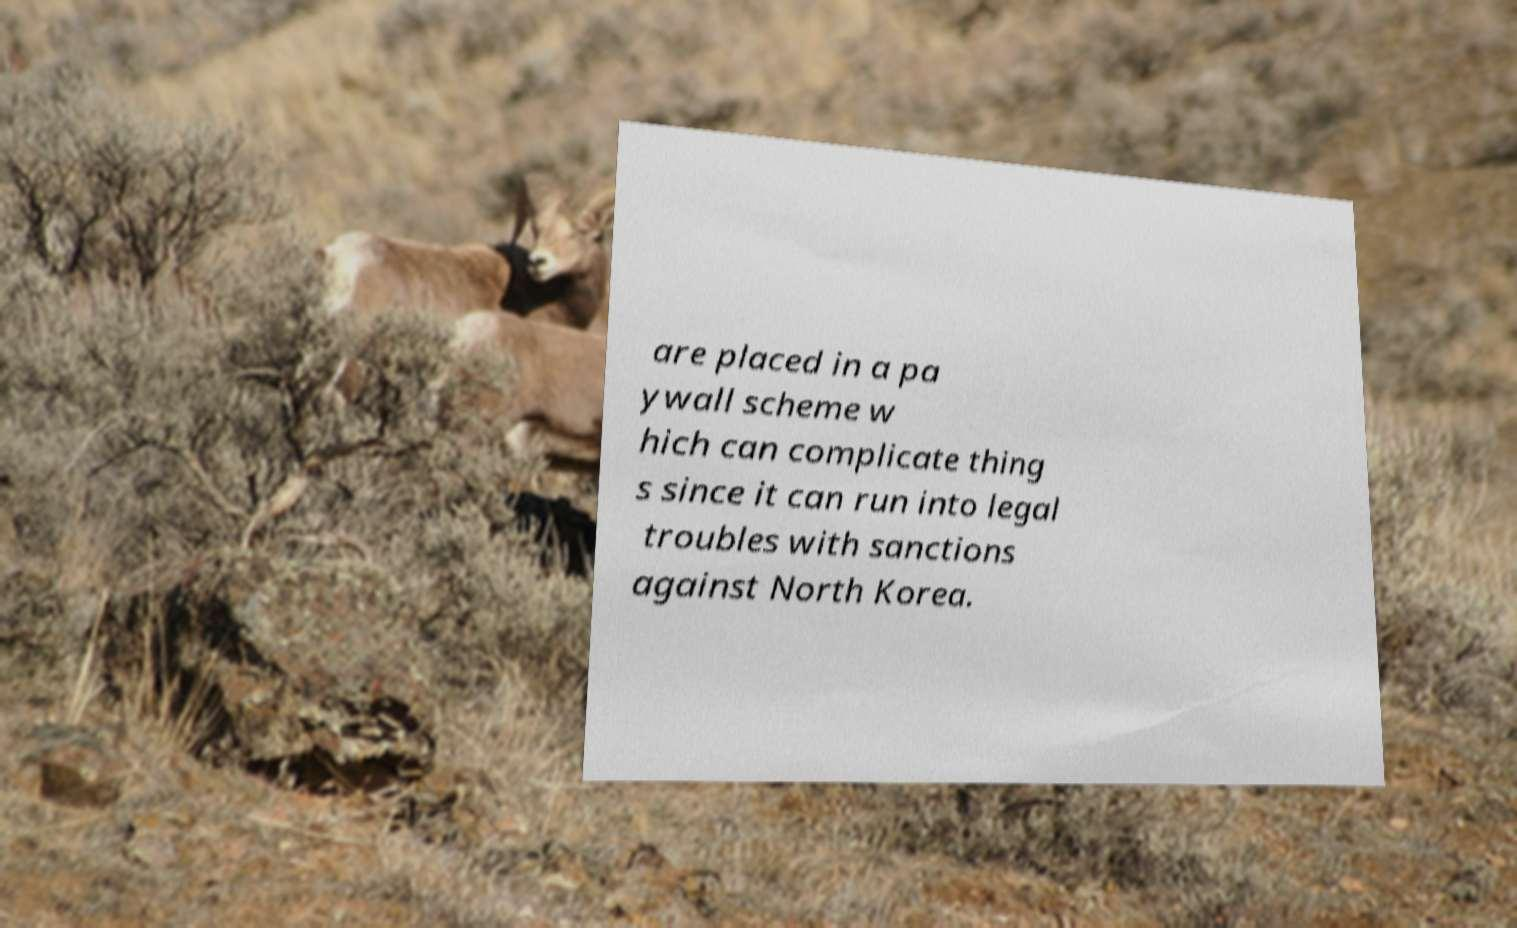Could you extract and type out the text from this image? are placed in a pa ywall scheme w hich can complicate thing s since it can run into legal troubles with sanctions against North Korea. 